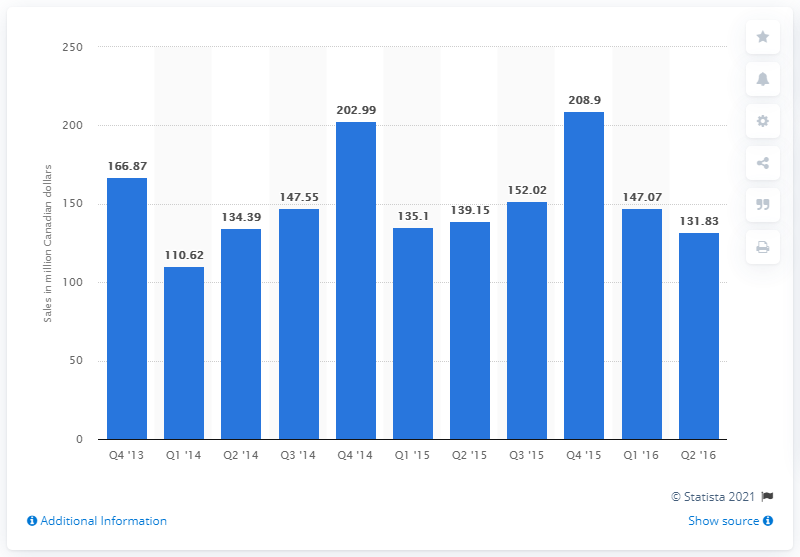Give some essential details in this illustration. According to the data provided, the total amount of craft and artists' supplies sold in Canada in the fourth quarter of 2013 was 166.87. 